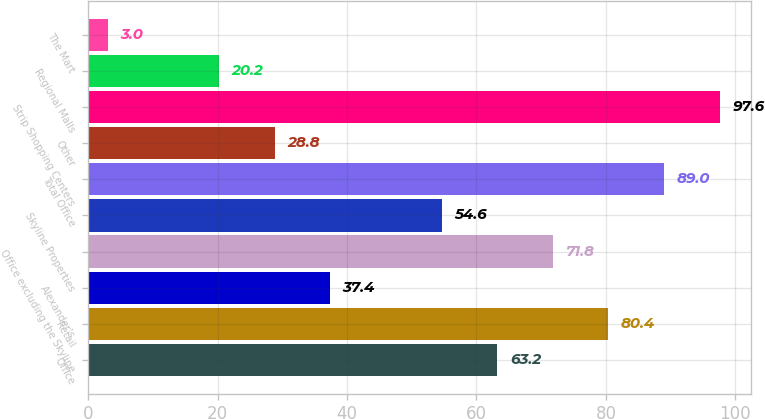Convert chart to OTSL. <chart><loc_0><loc_0><loc_500><loc_500><bar_chart><fcel>Office<fcel>Retail<fcel>Alexander's<fcel>Office excluding the Skyline<fcel>Skyline Properties<fcel>Total Office<fcel>Other<fcel>Strip Shopping Centers<fcel>Regional Malls<fcel>The Mart<nl><fcel>63.2<fcel>80.4<fcel>37.4<fcel>71.8<fcel>54.6<fcel>89<fcel>28.8<fcel>97.6<fcel>20.2<fcel>3<nl></chart> 